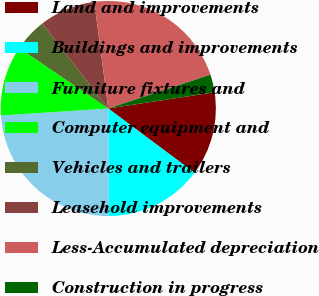<chart> <loc_0><loc_0><loc_500><loc_500><pie_chart><fcel>Land and improvements<fcel>Buildings and improvements<fcel>Furniture fixtures and<fcel>Computer equipment and<fcel>Vehicles and trailers<fcel>Leasehold improvements<fcel>Less-Accumulated depreciation<fcel>Construction in progress<nl><fcel>12.61%<fcel>14.7%<fcel>24.07%<fcel>10.53%<fcel>4.99%<fcel>8.44%<fcel>21.99%<fcel>2.67%<nl></chart> 